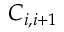<formula> <loc_0><loc_0><loc_500><loc_500>C _ { i , i + 1 }</formula> 